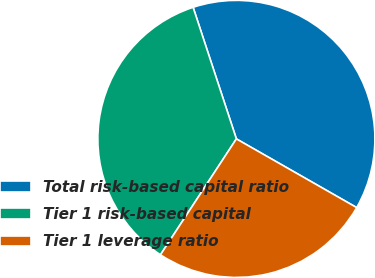Convert chart. <chart><loc_0><loc_0><loc_500><loc_500><pie_chart><fcel>Total risk-based capital ratio<fcel>Tier 1 risk-based capital<fcel>Tier 1 leverage ratio<nl><fcel>38.31%<fcel>35.71%<fcel>25.97%<nl></chart> 